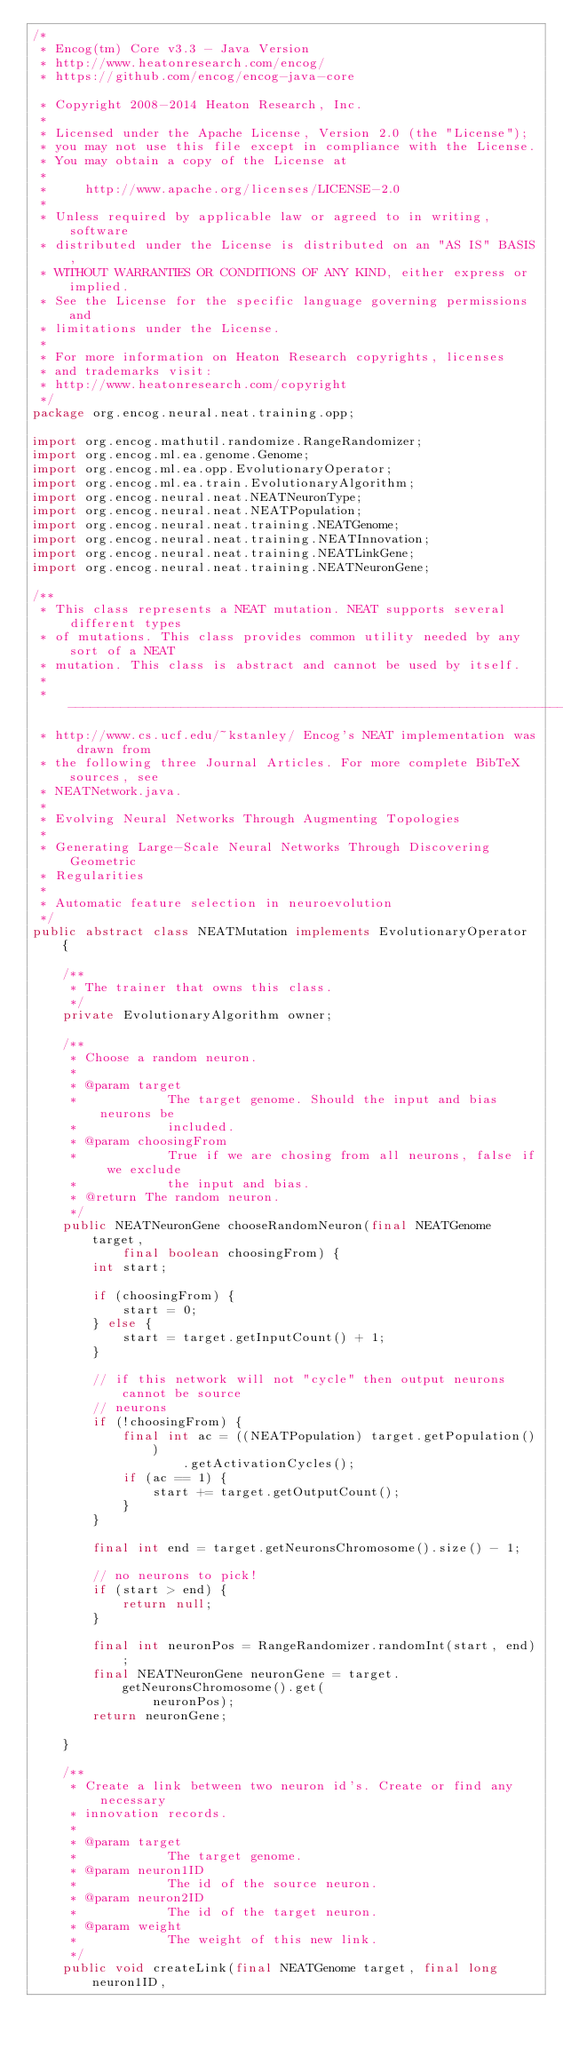<code> <loc_0><loc_0><loc_500><loc_500><_Java_>/*
 * Encog(tm) Core v3.3 - Java Version
 * http://www.heatonresearch.com/encog/
 * https://github.com/encog/encog-java-core
 
 * Copyright 2008-2014 Heaton Research, Inc.
 *
 * Licensed under the Apache License, Version 2.0 (the "License");
 * you may not use this file except in compliance with the License.
 * You may obtain a copy of the License at
 *
 *     http://www.apache.org/licenses/LICENSE-2.0
 *
 * Unless required by applicable law or agreed to in writing, software
 * distributed under the License is distributed on an "AS IS" BASIS,
 * WITHOUT WARRANTIES OR CONDITIONS OF ANY KIND, either express or implied.
 * See the License for the specific language governing permissions and
 * limitations under the License.
 *   
 * For more information on Heaton Research copyrights, licenses 
 * and trademarks visit:
 * http://www.heatonresearch.com/copyright
 */
package org.encog.neural.neat.training.opp;

import org.encog.mathutil.randomize.RangeRandomizer;
import org.encog.ml.ea.genome.Genome;
import org.encog.ml.ea.opp.EvolutionaryOperator;
import org.encog.ml.ea.train.EvolutionaryAlgorithm;
import org.encog.neural.neat.NEATNeuronType;
import org.encog.neural.neat.NEATPopulation;
import org.encog.neural.neat.training.NEATGenome;
import org.encog.neural.neat.training.NEATInnovation;
import org.encog.neural.neat.training.NEATLinkGene;
import org.encog.neural.neat.training.NEATNeuronGene;

/**
 * This class represents a NEAT mutation. NEAT supports several different types
 * of mutations. This class provides common utility needed by any sort of a NEAT
 * mutation. This class is abstract and cannot be used by itself.
 * 
 * -----------------------------------------------------------------------------
 * http://www.cs.ucf.edu/~kstanley/ Encog's NEAT implementation was drawn from
 * the following three Journal Articles. For more complete BibTeX sources, see
 * NEATNetwork.java.
 * 
 * Evolving Neural Networks Through Augmenting Topologies
 * 
 * Generating Large-Scale Neural Networks Through Discovering Geometric
 * Regularities
 * 
 * Automatic feature selection in neuroevolution
 */
public abstract class NEATMutation implements EvolutionaryOperator {

	/**
	 * The trainer that owns this class.
	 */
	private EvolutionaryAlgorithm owner;

	/**
	 * Choose a random neuron.
	 * 
	 * @param target
	 *            The target genome. Should the input and bias neurons be
	 *            included.
	 * @param choosingFrom
	 *            True if we are chosing from all neurons, false if we exclude
	 *            the input and bias.
	 * @return The random neuron.
	 */
	public NEATNeuronGene chooseRandomNeuron(final NEATGenome target,
			final boolean choosingFrom) {
		int start;

		if (choosingFrom) {
			start = 0;
		} else {
			start = target.getInputCount() + 1;
		}

		// if this network will not "cycle" then output neurons cannot be source
		// neurons
		if (!choosingFrom) {
			final int ac = ((NEATPopulation) target.getPopulation())
					.getActivationCycles();
			if (ac == 1) {
				start += target.getOutputCount();
			}
		}

		final int end = target.getNeuronsChromosome().size() - 1;

		// no neurons to pick!
		if (start > end) {
			return null;
		}

		final int neuronPos = RangeRandomizer.randomInt(start, end);
		final NEATNeuronGene neuronGene = target.getNeuronsChromosome().get(
				neuronPos);
		return neuronGene;

	}

	/**
	 * Create a link between two neuron id's. Create or find any necessary
	 * innovation records.
	 * 
	 * @param target
	 *            The target genome.
	 * @param neuron1ID
	 *            The id of the source neuron.
	 * @param neuron2ID
	 *            The id of the target neuron.
	 * @param weight
	 *            The weight of this new link.
	 */
	public void createLink(final NEATGenome target, final long neuron1ID,</code> 